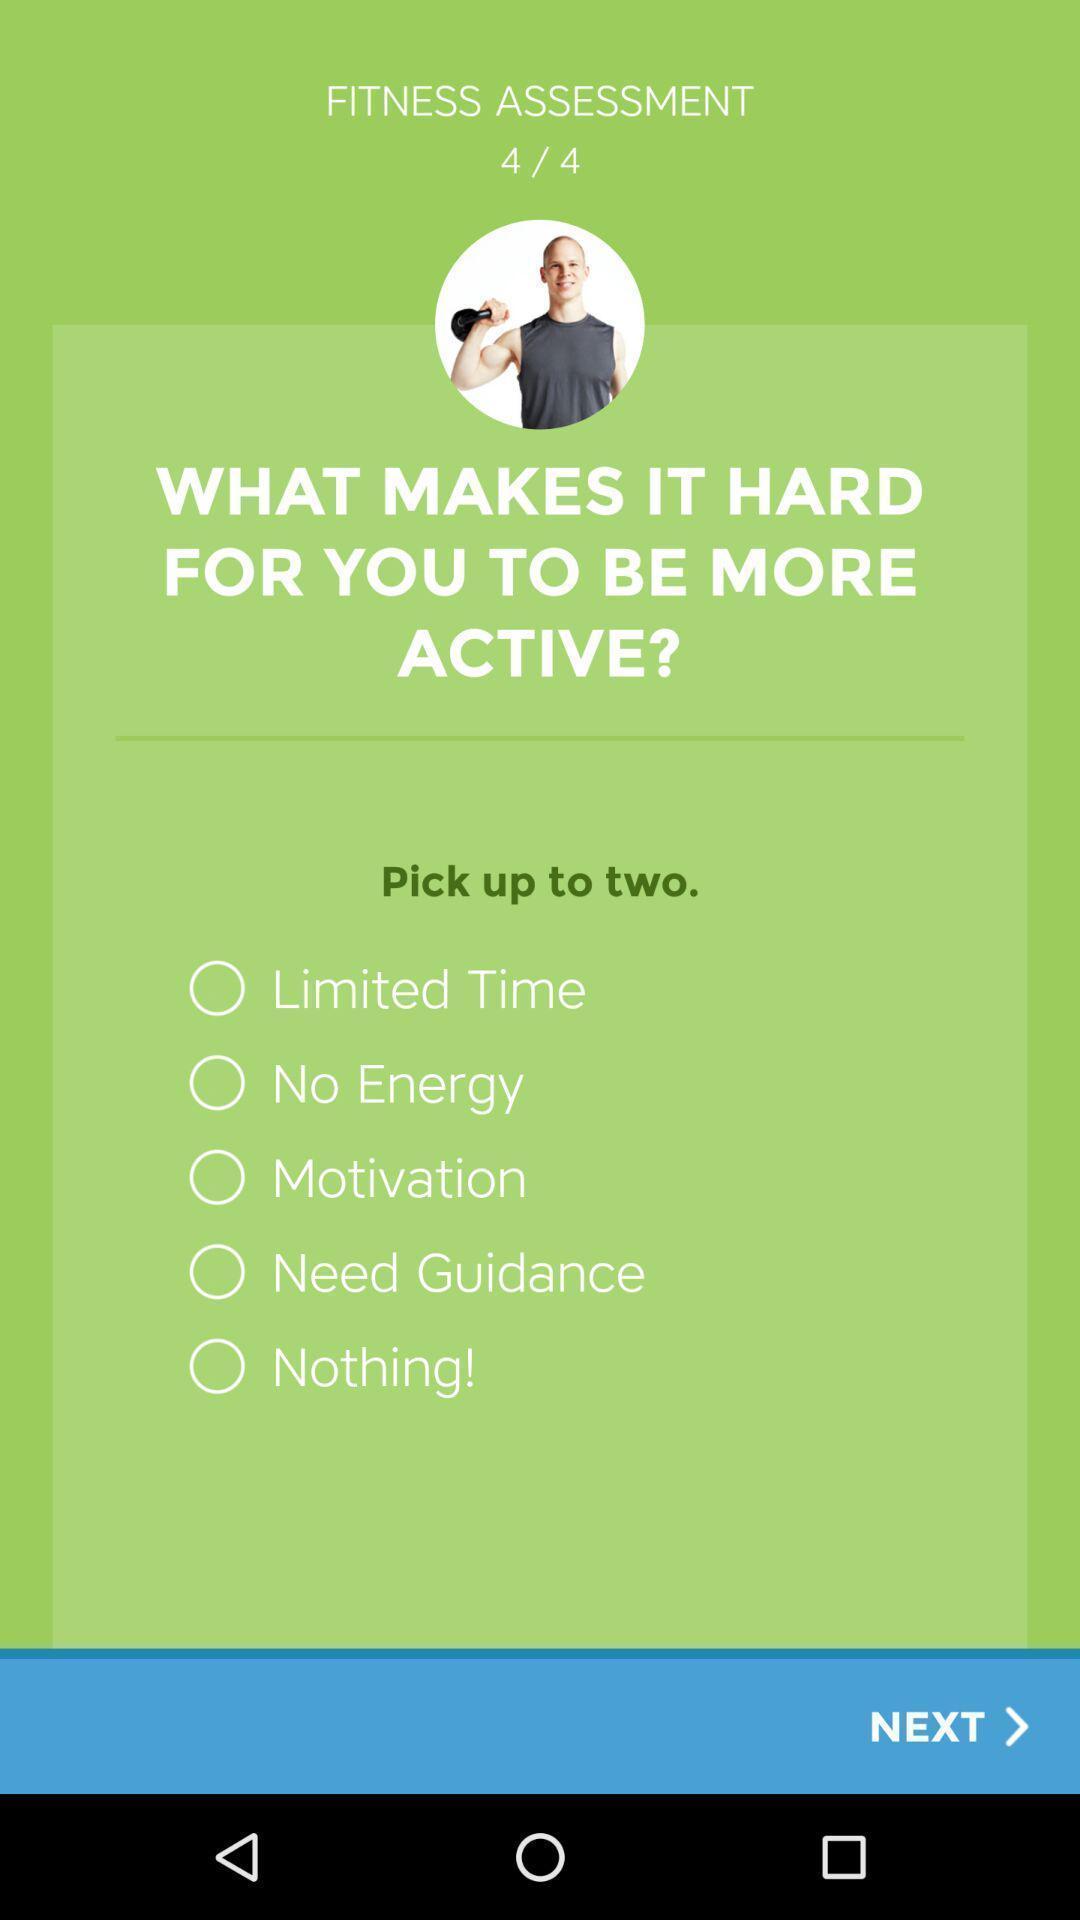Describe the content in this image. Page displaying to select an option for the given question. 